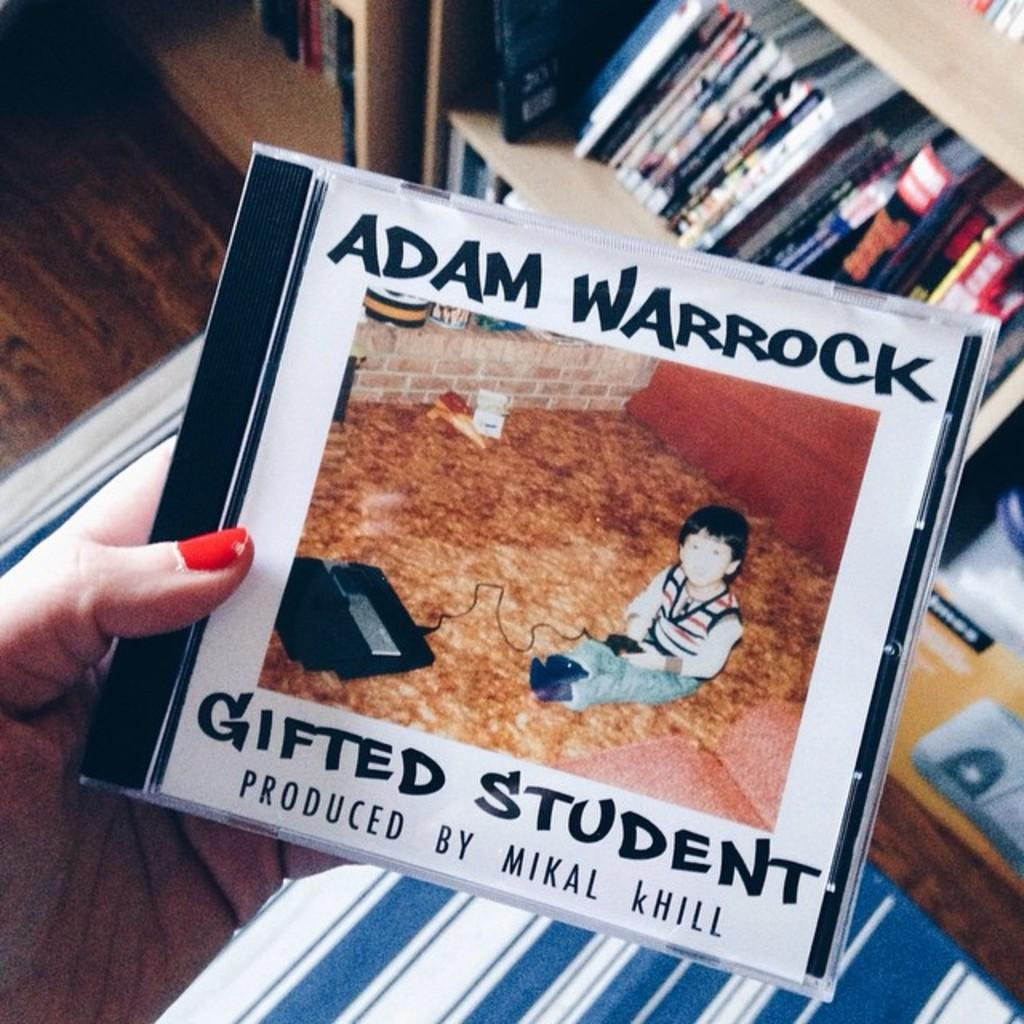<image>
Describe the image concisely. A CD  of Adam Warrock title Gifted Student produced by Mikal Khill. 